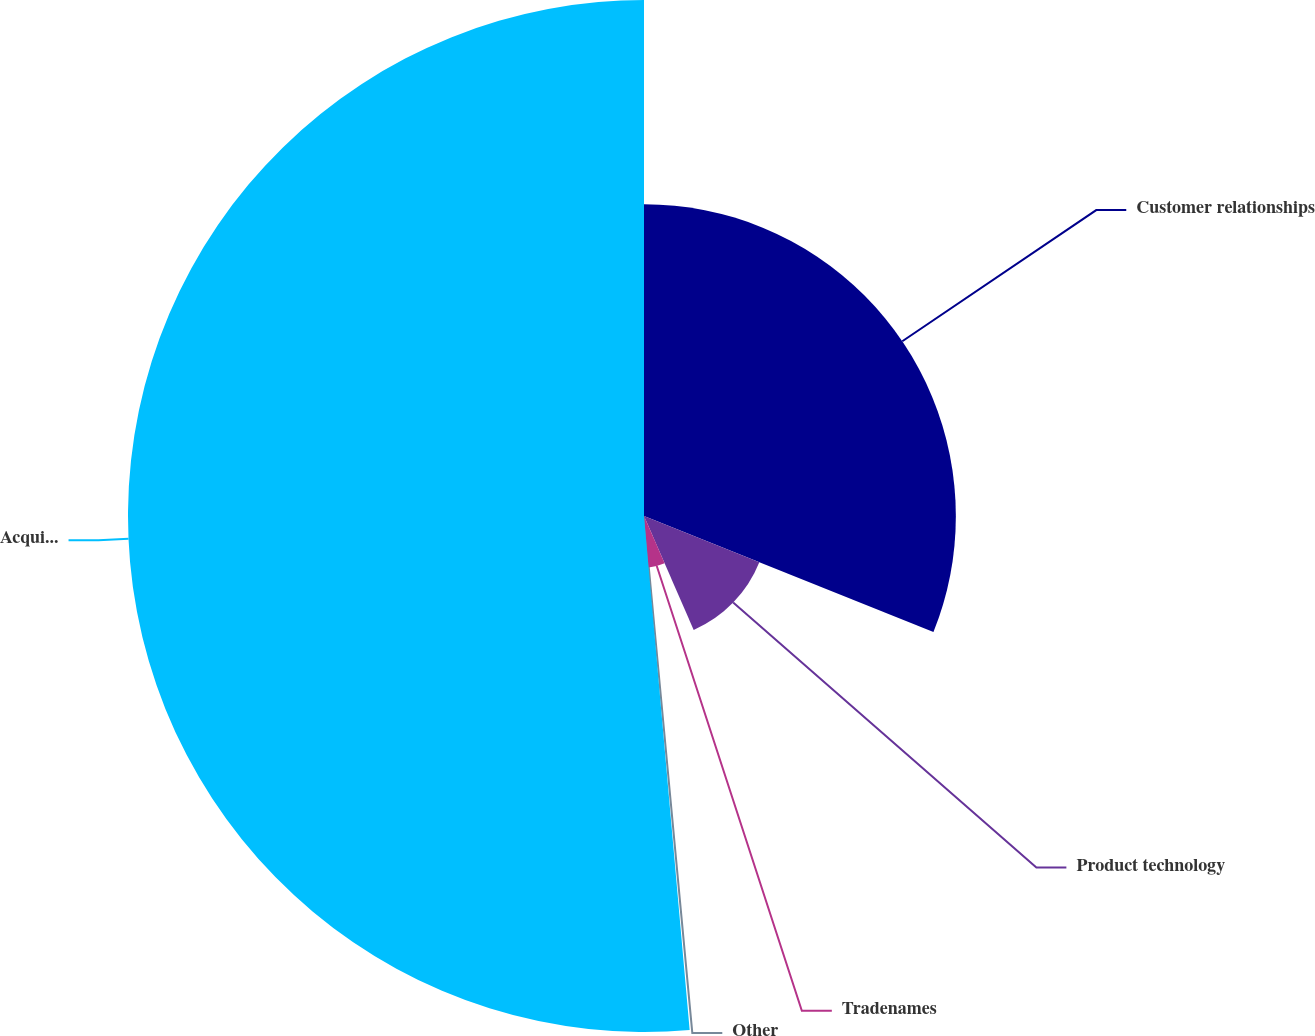<chart> <loc_0><loc_0><loc_500><loc_500><pie_chart><fcel>Customer relationships<fcel>Product technology<fcel>Tradenames<fcel>Other<fcel>Acquisition-related Intangible<nl><fcel>31.07%<fcel>12.38%<fcel>5.14%<fcel>0.0%<fcel>51.41%<nl></chart> 